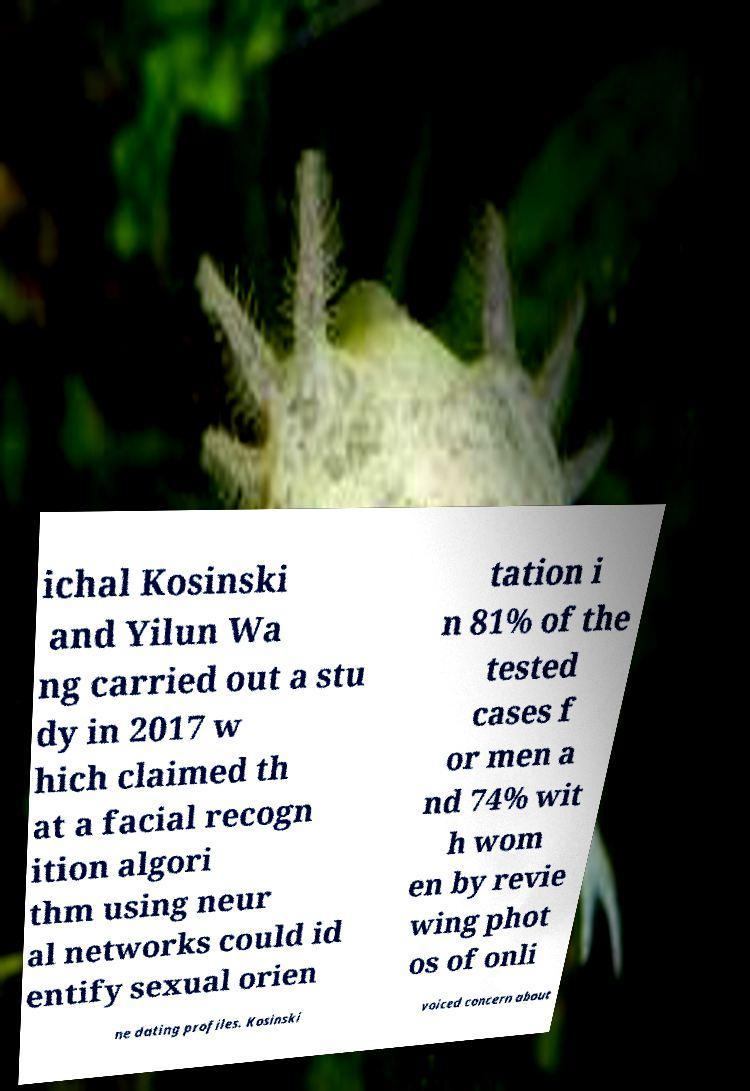For documentation purposes, I need the text within this image transcribed. Could you provide that? ichal Kosinski and Yilun Wa ng carried out a stu dy in 2017 w hich claimed th at a facial recogn ition algori thm using neur al networks could id entify sexual orien tation i n 81% of the tested cases f or men a nd 74% wit h wom en by revie wing phot os of onli ne dating profiles. Kosinski voiced concern about 